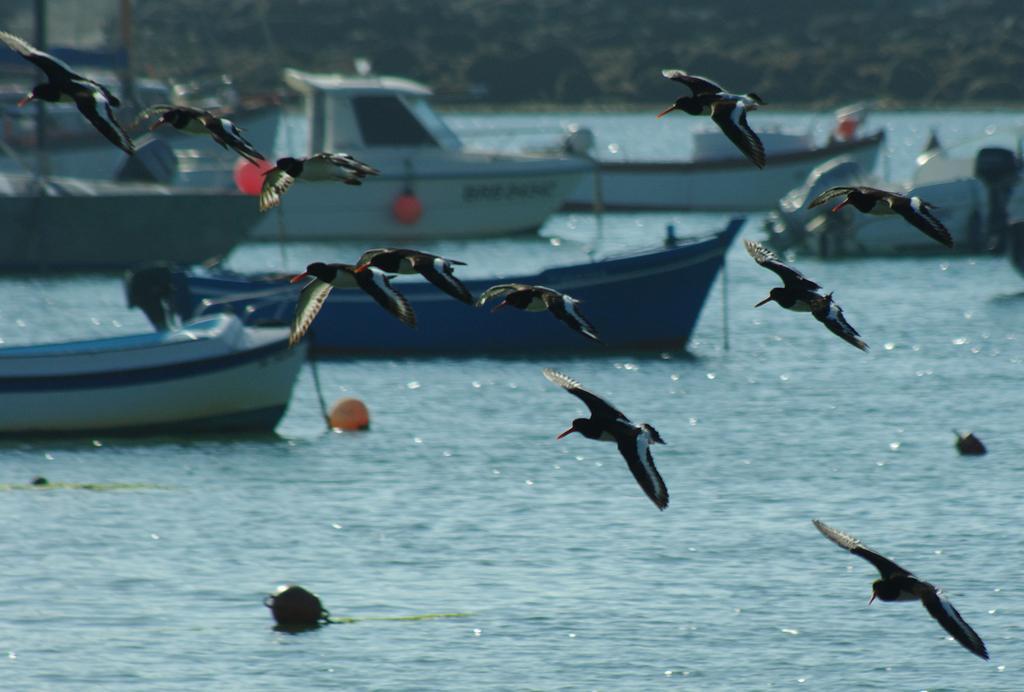Could you give a brief overview of what you see in this image? In this image in the foreground there are some birds which are flying at the bottom there is a river, in that river there are some boats and in the background there are trees. 